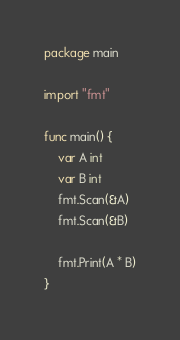<code> <loc_0><loc_0><loc_500><loc_500><_Go_>package main

import "fmt"

func main() {
	var A int
	var B int
	fmt.Scan(&A)
	fmt.Scan(&B)

	fmt.Print(A * B)
}
</code> 